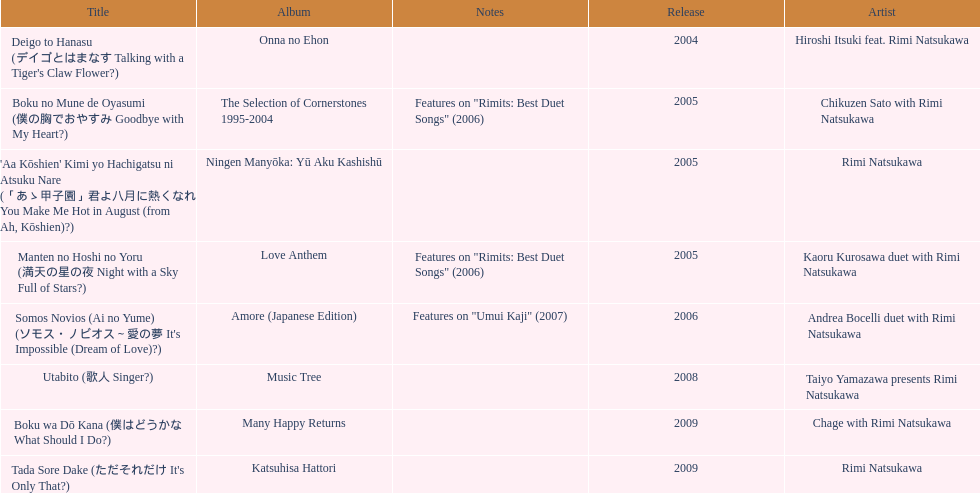What was the album released immediately before the one that had boku wa do kana on it? Music Tree. 